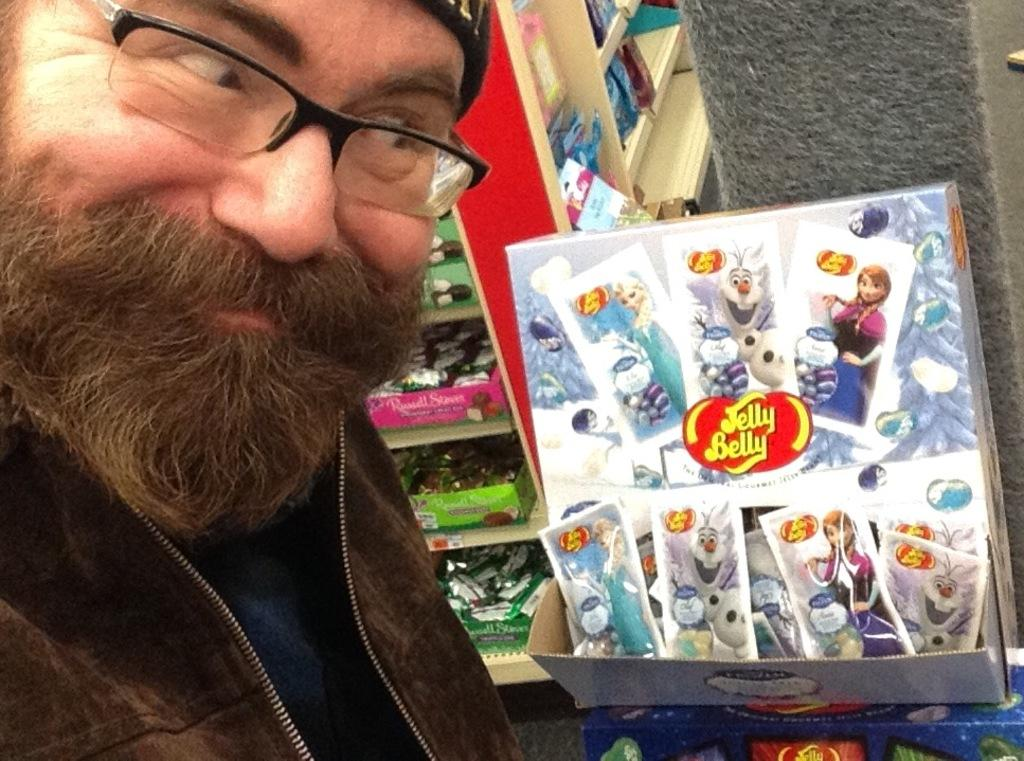What is the person in the image doing? The person is taking a selfie in the image. What can be seen in the background of the image? There is a shelf in the image. What is on the shelf? There are toy boxes on the shelf. What type of powder is being used by the person in the image? There is no powder visible in the image, and the person is taking a selfie, not applying any makeup or substances. 